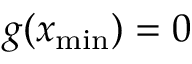<formula> <loc_0><loc_0><loc_500><loc_500>g ( x _ { \min } ) = 0</formula> 